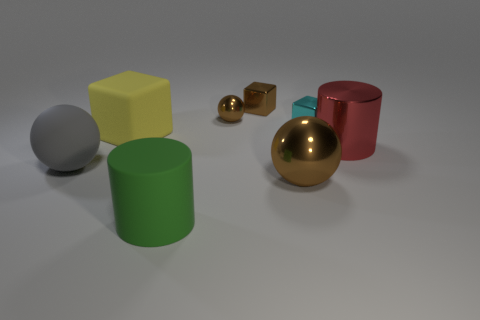There is a thing in front of the brown thing that is in front of the cylinder behind the green rubber object; how big is it?
Make the answer very short. Large. How many other things are the same color as the small metallic sphere?
Provide a short and direct response. 2. Is the color of the large sphere that is to the right of the rubber block the same as the matte cylinder?
Your answer should be very brief. No. How many objects are big blue matte spheres or brown balls?
Provide a succinct answer. 2. What color is the metallic object that is in front of the gray matte sphere?
Make the answer very short. Brown. Are there fewer yellow blocks that are on the right side of the cyan thing than large gray balls?
Ensure brevity in your answer.  Yes. There is another metallic ball that is the same color as the small sphere; what size is it?
Offer a very short reply. Large. Does the cyan thing have the same material as the gray ball?
Provide a succinct answer. No. What number of objects are either tiny blocks that are behind the cyan thing or brown spheres in front of the yellow object?
Provide a short and direct response. 2. Are there any matte blocks of the same size as the cyan metal cube?
Your answer should be very brief. No. 